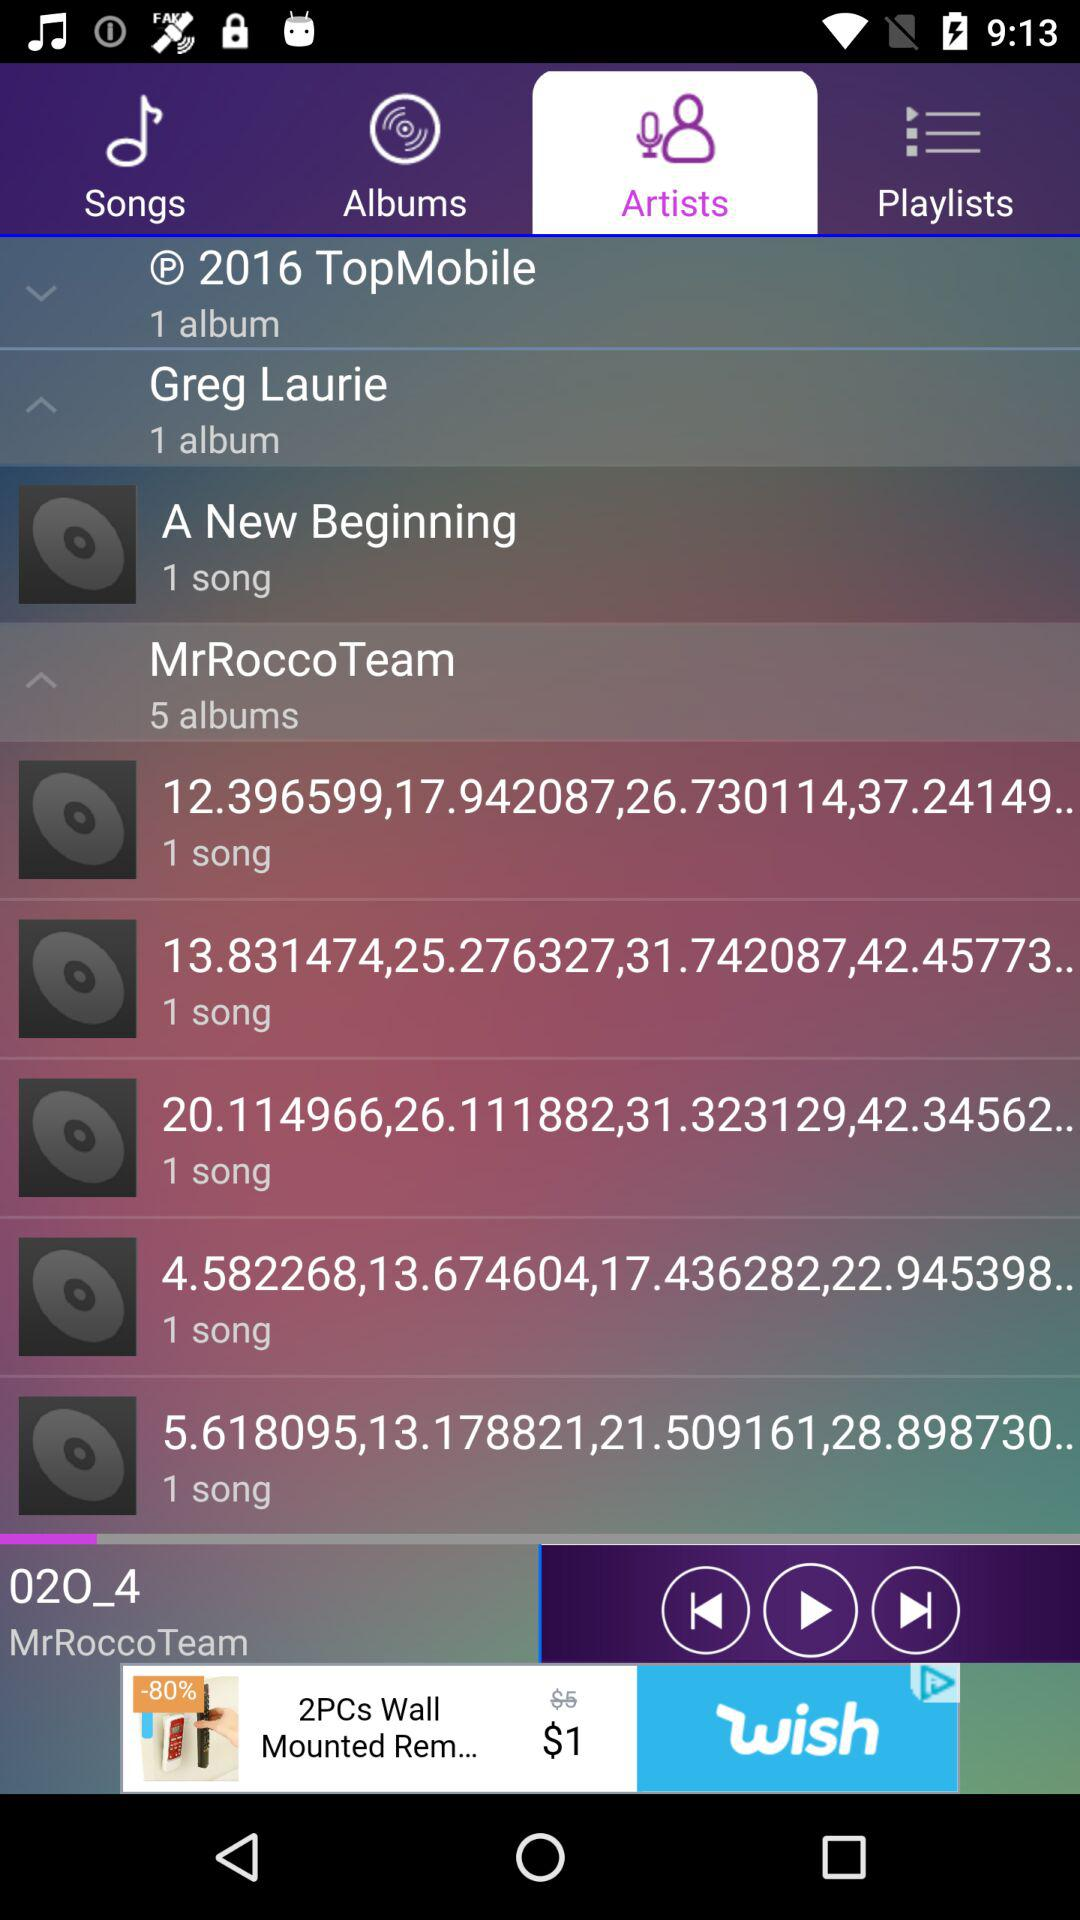Which tab is selected? The selected tab is "Artists". 